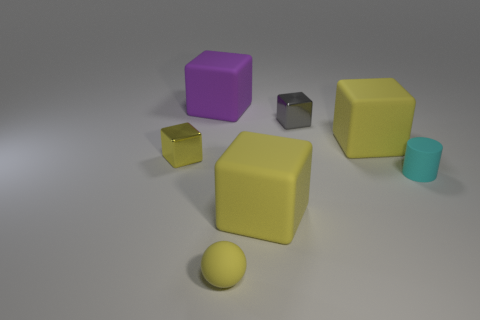Subtract all yellow cylinders. How many yellow cubes are left? 3 Subtract all gray blocks. How many blocks are left? 4 Subtract 2 cubes. How many cubes are left? 3 Subtract all big yellow rubber blocks. How many blocks are left? 3 Subtract all blue blocks. Subtract all red cylinders. How many blocks are left? 5 Add 1 small rubber objects. How many objects exist? 8 Subtract all spheres. How many objects are left? 6 Add 5 cyan things. How many cyan things are left? 6 Add 2 tiny yellow balls. How many tiny yellow balls exist? 3 Subtract 0 green balls. How many objects are left? 7 